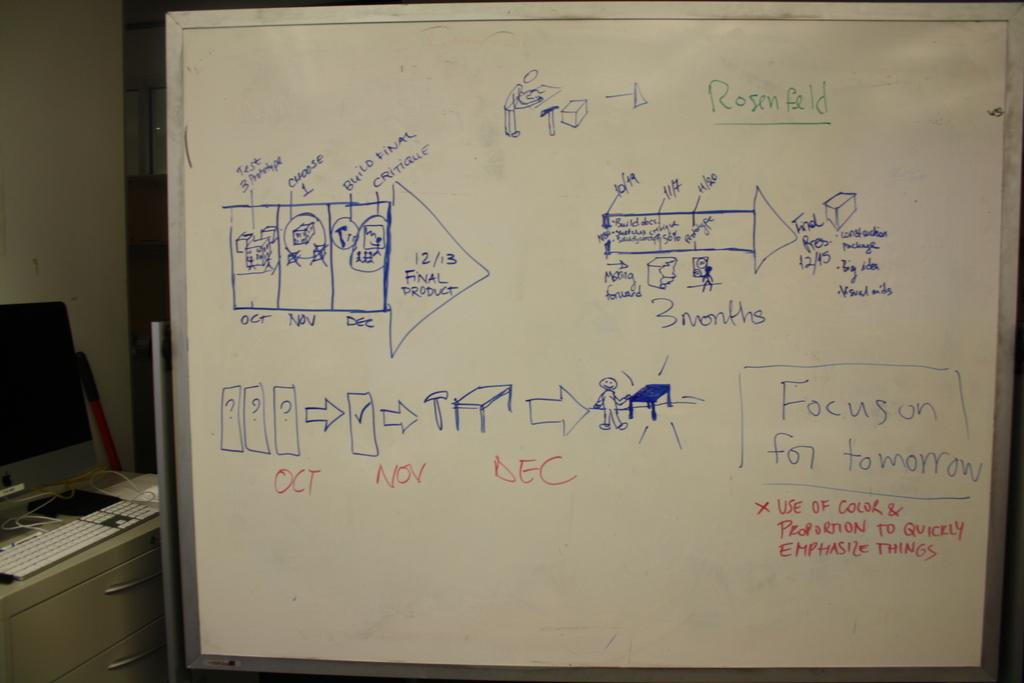<image>
Offer a succinct explanation of the picture presented. A white board reads what to "focus on for tomorrow." 